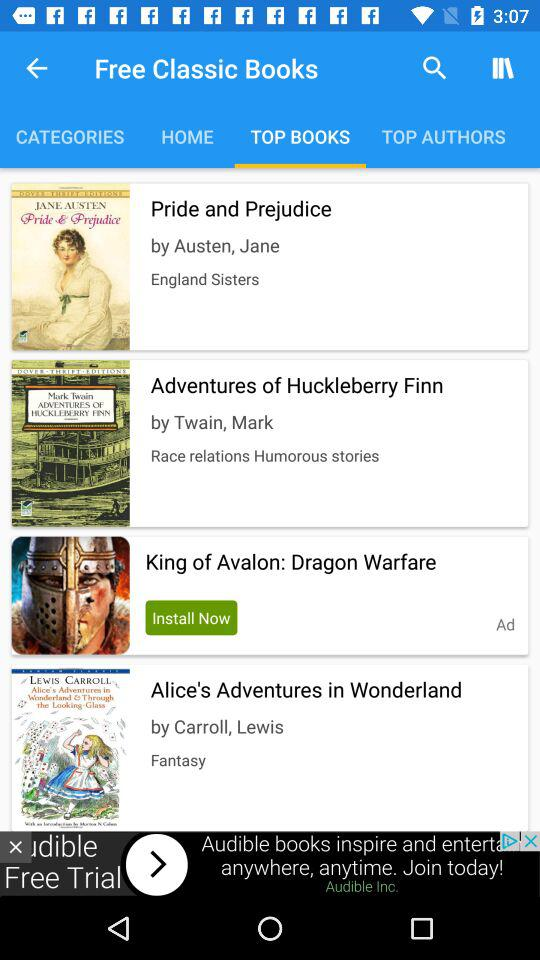Who is the writer of "Alice's Adventures in Wonderland"? The writer is Carroll, Lewis. 